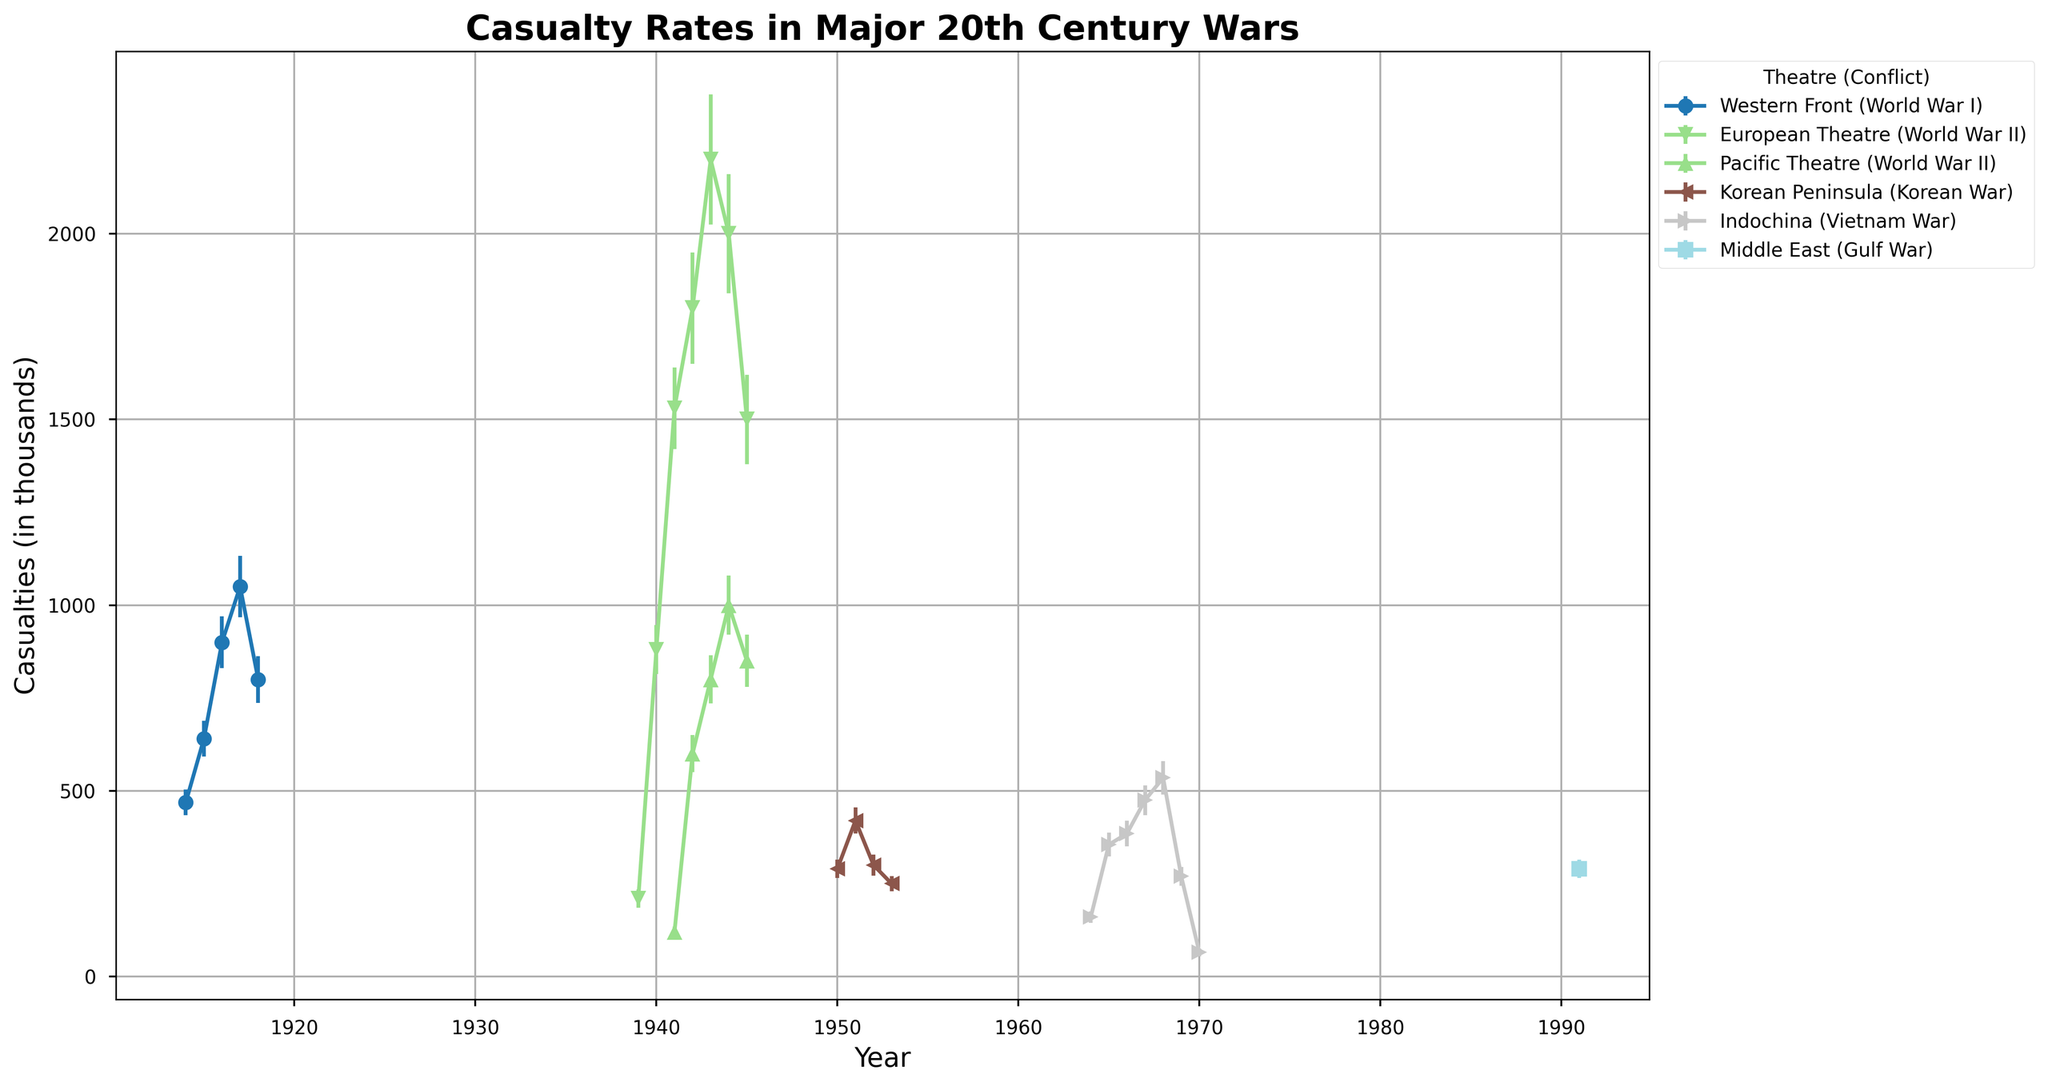Which conflict had the highest casualty rate in 1943 and how does it compare to the other theatres in the same year? In 1943, World War II in the European Theatre had the highest casualty rate with 2200 thousand. Comparing it to the Pacific Theatre which had 800 thousand and other theatres in different conflicts, it had the highest rate that year.
Answer: World War II in the European Theatre had the highest casualty rate with 2200 thousand Between the years 1941 and 1945, which year had the lowest casualty rate in the Pacific Theatre during World War II? Referring to the Pacific Theatre for World War II from 1941 to 1945, the years and their casualty rates are 120, 600, 800, 1000, and 850 respectively. The lowest casualty rate is in 1941.
Answer: 1941 What is the total casualty rate for World War I on the Western Front from 1914 to 1918? Summing the casualty rates for World War I on the Western Front from 1914 to 1918: 469 + 640 + 900 + 1050 + 800 = 3859 thousand.
Answer: 3859 thousand Compare the casualty rates between the European Theatre and the Pacific Theatre in 1944 during World War II. Which one is higher and by how much? In 1944, the European Theatre had a casualty rate of 2000 thousand while the Pacific Theatre had 1000 thousand. The European Theatre had a higher rate by 1000 thousand.
Answer: European Theatre was higher by 1000 thousand Which conflict and theatre experienced a decrease in casualty rate from the previous year in 1918, and what was the difference? World War I on the Western Front experienced a decrease from 1917 to 1918. The casualty rates were 1050 in 1917 and 800 in 1918. The difference is 1050 - 800 = 250 thousand.
Answer: World War I on the Western Front with a difference of 250 thousand During the Korean War on the Korean Peninsula, which year had the highest casualty rate and what was it? Comparing the casualty rates during the Korean War on the Korean Peninsula: 290 (1950), 420 (1951), 300 (1952), 250 (1953). The highest was in 1951 with 420 thousand.
Answer: 1951 with 420 thousand Across all theatres and conflicts shown, which year recorded the maximum casualty rate and what was the rate? By examining all casualty rates across all years and conflicts, the highest recorded rate is in 1943 during World War II in the European Theatre with 2200 thousand.
Answer: 1943 with 2200 thousand 